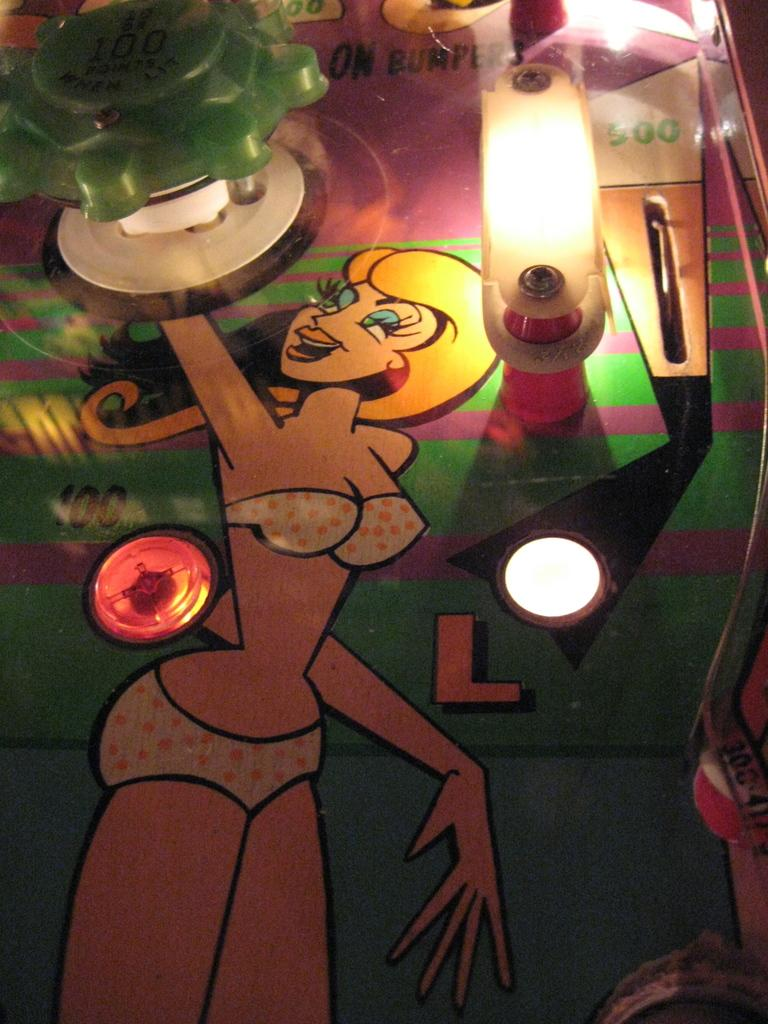What is the main subject of the image? The main subject of the image is a painting. Are there any additional features attached to the painting? Yes, electric lights are attached to the painting. What type of cloud can be seen in the painting? There is no cloud visible in the painting, as the image only shows a painting with electric lights attached to it. 